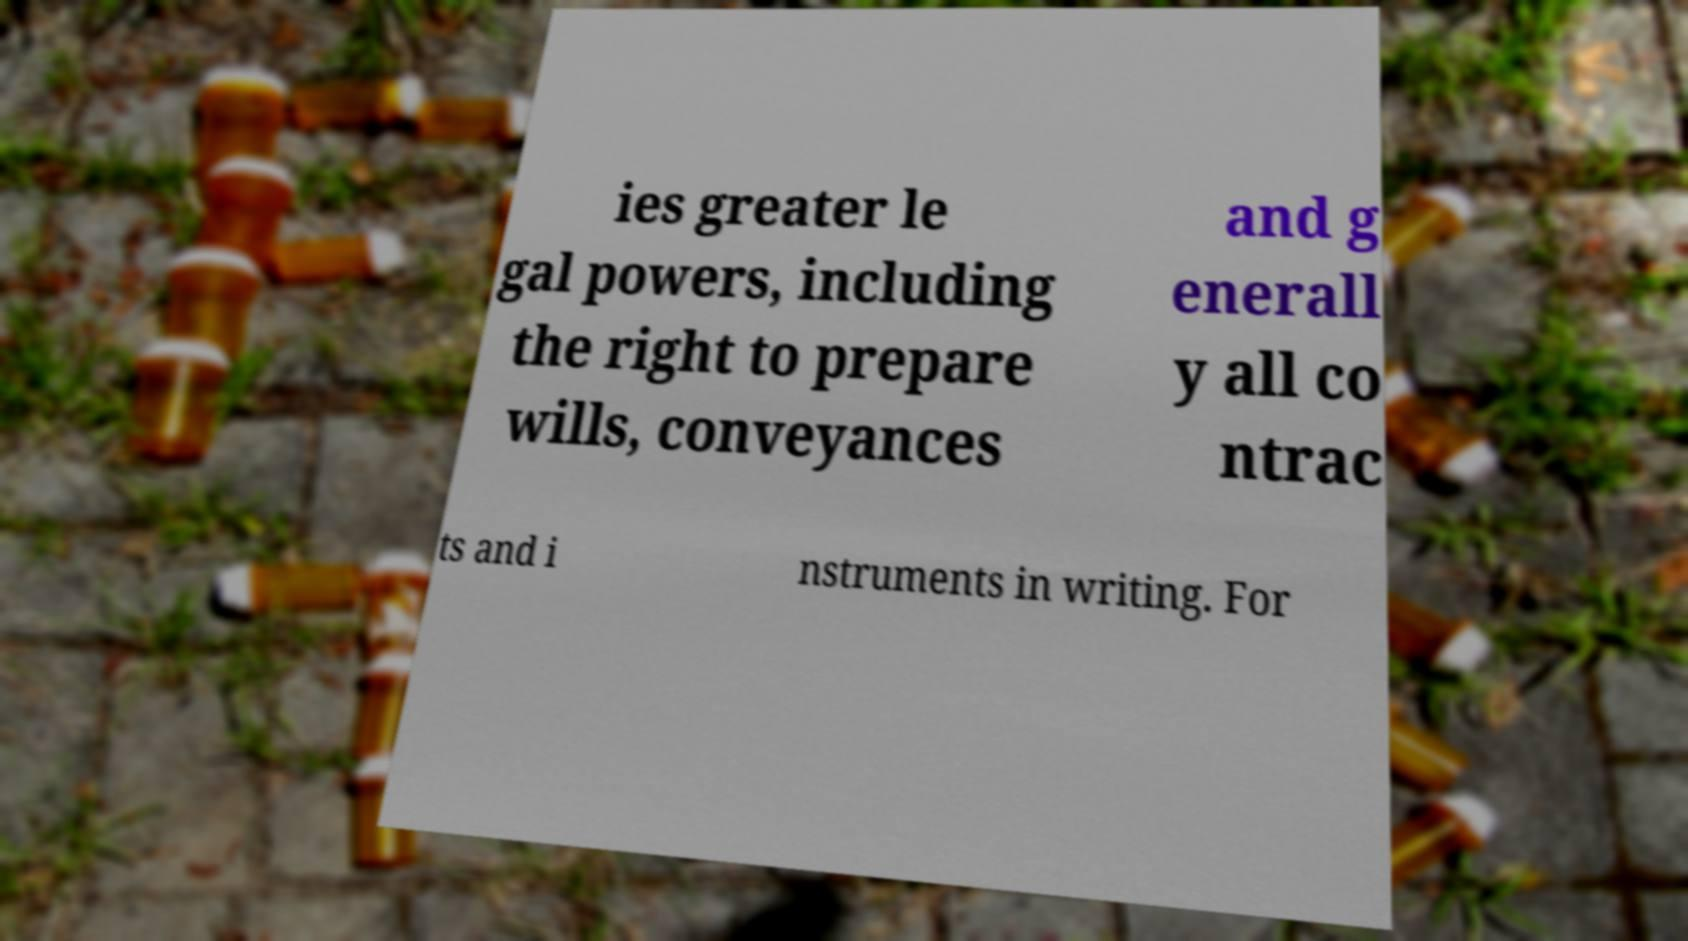Please read and relay the text visible in this image. What does it say? ies greater le gal powers, including the right to prepare wills, conveyances and g enerall y all co ntrac ts and i nstruments in writing. For 